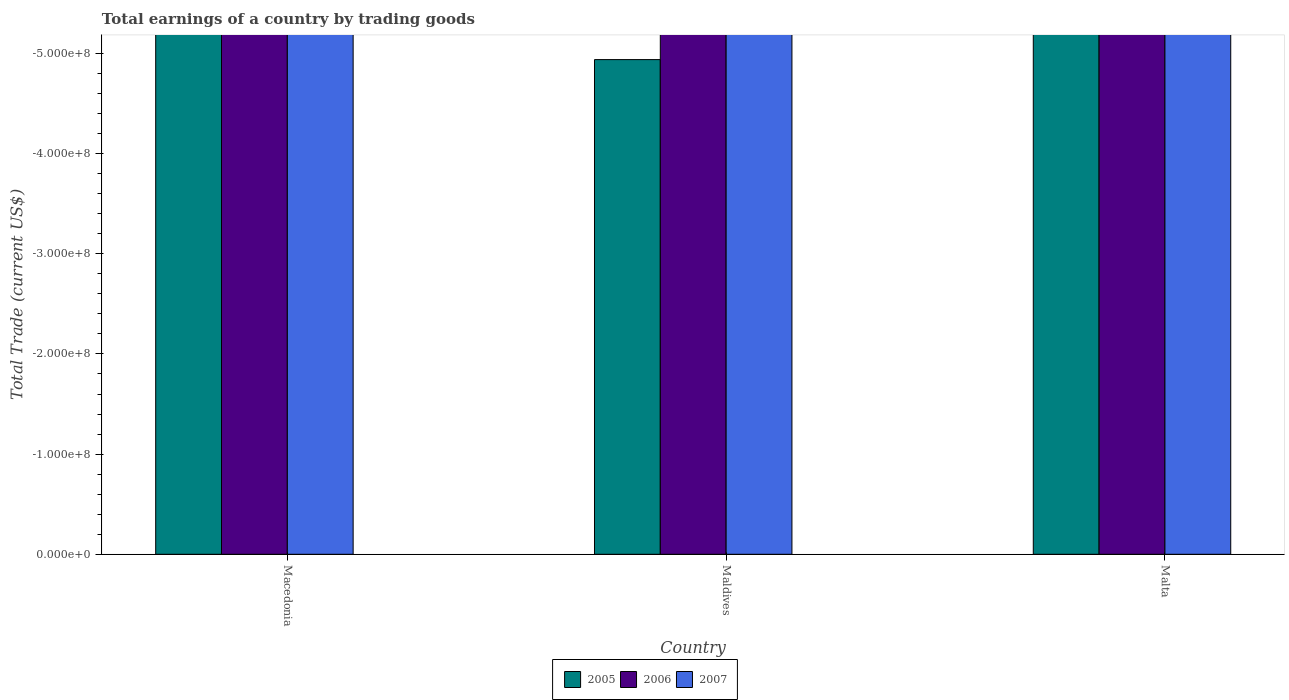How many different coloured bars are there?
Provide a short and direct response. 0. How many bars are there on the 2nd tick from the left?
Make the answer very short. 0. How many bars are there on the 3rd tick from the right?
Your answer should be very brief. 0. What is the label of the 3rd group of bars from the left?
Make the answer very short. Malta. What is the average total earnings in 2007 per country?
Make the answer very short. 0. In how many countries, is the total earnings in 2005 greater than the average total earnings in 2005 taken over all countries?
Provide a short and direct response. 0. Are all the bars in the graph horizontal?
Ensure brevity in your answer.  No. How many countries are there in the graph?
Ensure brevity in your answer.  3. What is the difference between two consecutive major ticks on the Y-axis?
Offer a terse response. 1.00e+08. Does the graph contain any zero values?
Make the answer very short. Yes. How are the legend labels stacked?
Offer a very short reply. Horizontal. What is the title of the graph?
Provide a succinct answer. Total earnings of a country by trading goods. Does "1987" appear as one of the legend labels in the graph?
Offer a very short reply. No. What is the label or title of the Y-axis?
Provide a succinct answer. Total Trade (current US$). What is the Total Trade (current US$) of 2005 in Macedonia?
Keep it short and to the point. 0. What is the Total Trade (current US$) in 2007 in Macedonia?
Keep it short and to the point. 0. What is the Total Trade (current US$) of 2005 in Maldives?
Offer a terse response. 0. What is the Total Trade (current US$) in 2006 in Maldives?
Your answer should be compact. 0. What is the Total Trade (current US$) of 2007 in Maldives?
Make the answer very short. 0. What is the Total Trade (current US$) in 2005 in Malta?
Your answer should be compact. 0. What is the Total Trade (current US$) in 2007 in Malta?
Your answer should be very brief. 0. What is the total Total Trade (current US$) in 2005 in the graph?
Provide a succinct answer. 0. What is the total Total Trade (current US$) in 2006 in the graph?
Provide a short and direct response. 0. What is the total Total Trade (current US$) of 2007 in the graph?
Your response must be concise. 0. What is the average Total Trade (current US$) in 2005 per country?
Keep it short and to the point. 0. 